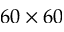<formula> <loc_0><loc_0><loc_500><loc_500>6 0 \times 6 0</formula> 